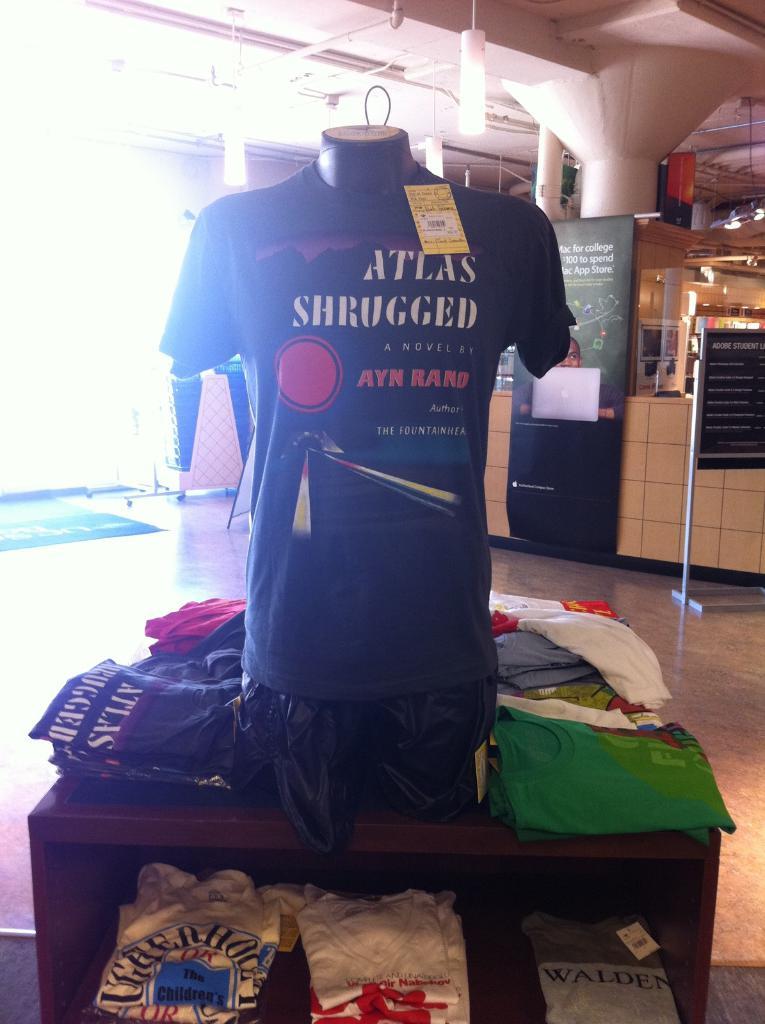What is the name of the novel by ayn rand?
Your answer should be very brief. Atlas shrugged. Who is the author of this novel?
Offer a very short reply. Ayn rand. 